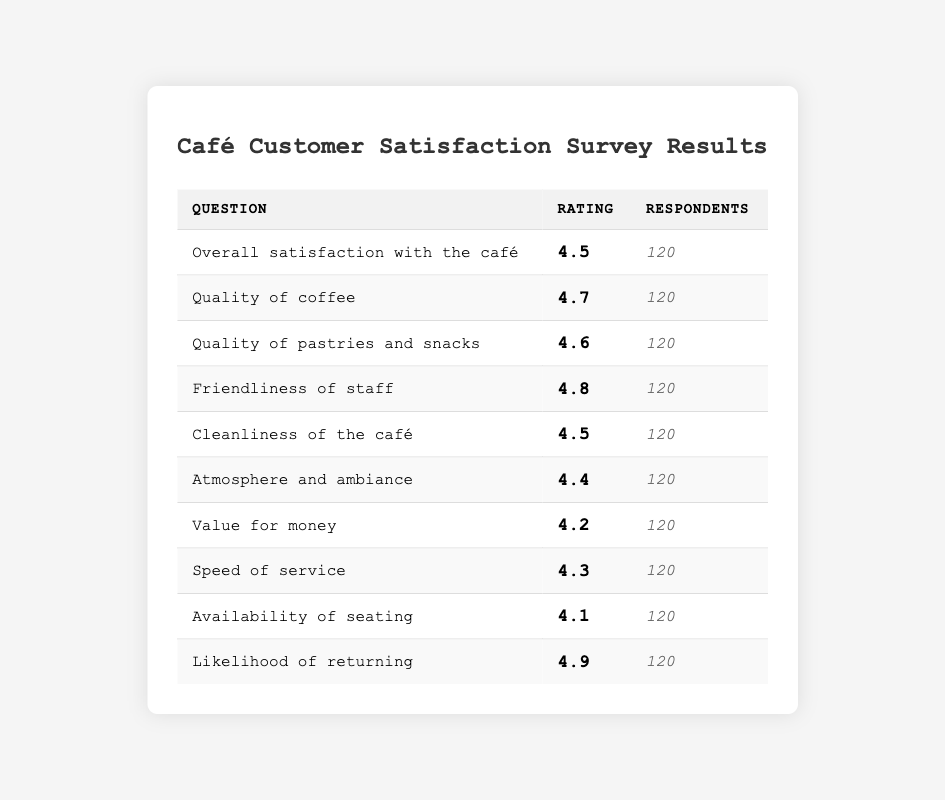What is the rating for the quality of coffee? The table lists the "Quality of coffee" rating as 4.7 under the "Rating" column.
Answer: 4.7 How many respondents participated in the survey? The number of respondents is consistently noted as 120 for each question in the "Respondents" column.
Answer: 120 Which aspect of the café received the highest rating? Looking through the ratings, "Likelihood of returning" has the highest rating of 4.9.
Answer: 4.9 What is the average rating for cleanliness and atmosphere combined? To find the average, I’ll first sum the ratings for "Cleanliness of the café" (4.5) and "Atmosphere and ambiance" (4.4), giving (4.5 + 4.4) = 8.9. Then, divide by 2, resulting in 8.9 / 2 = 4.45.
Answer: 4.45 Is the rating for "Friendliness of staff" higher than that for "Speed of service"? The rating for "Friendliness of staff" is 4.8, while "Speed of service" has a rating of 4.3. Since 4.8 is greater than 4.3, the statement is true.
Answer: Yes What is the difference between the ratings for "Value for money" and "Availability of seating"? The rating for "Value for money" is 4.2, and "Availability of seating" is 4.1. The difference is 4.2 - 4.1 = 0.1.
Answer: 0.1 How does the rating for "Quality of pastries and snacks" compare to that of "Quality of coffee"? "Quality of pastries and snacks" has a rating of 4.6, which is lower than the 4.7 rating for "Quality of coffee". Therefore, "Quality of pastries and snacks" is lower.
Answer: Lower What percentage of respondents are satisfied with "Overall satisfaction with the café"? The "Overall satisfaction with the café" rating is 4.5. To find the percentage, I note that this is a rating out of 5; thus, (4.5/5) x 100 = 90%.
Answer: 90% Which two areas have ratings that are closest in value? By examining the table, "Availability of seating" (4.1) and "Value for money" (4.2) have the closest ratings.
Answer: 4.1 and 4.2 Which ratings are below 4.5? According to the table, "Availability of seating" (4.1) and "Value for money" (4.2) are below 4.5.
Answer: 4.1 and 4.2 